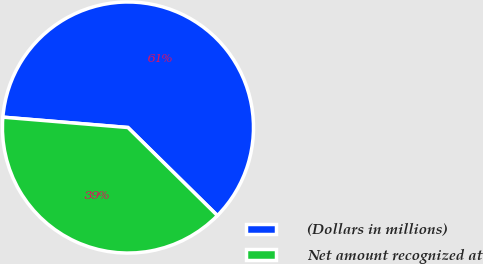<chart> <loc_0><loc_0><loc_500><loc_500><pie_chart><fcel>(Dollars in millions)<fcel>Net amount recognized at<nl><fcel>61.06%<fcel>38.94%<nl></chart> 